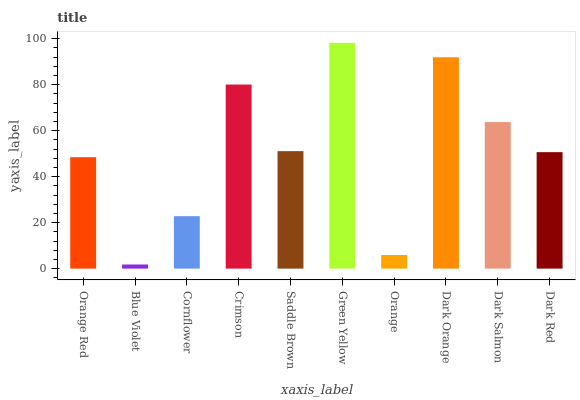Is Blue Violet the minimum?
Answer yes or no. Yes. Is Green Yellow the maximum?
Answer yes or no. Yes. Is Cornflower the minimum?
Answer yes or no. No. Is Cornflower the maximum?
Answer yes or no. No. Is Cornflower greater than Blue Violet?
Answer yes or no. Yes. Is Blue Violet less than Cornflower?
Answer yes or no. Yes. Is Blue Violet greater than Cornflower?
Answer yes or no. No. Is Cornflower less than Blue Violet?
Answer yes or no. No. Is Saddle Brown the high median?
Answer yes or no. Yes. Is Dark Red the low median?
Answer yes or no. Yes. Is Blue Violet the high median?
Answer yes or no. No. Is Cornflower the low median?
Answer yes or no. No. 